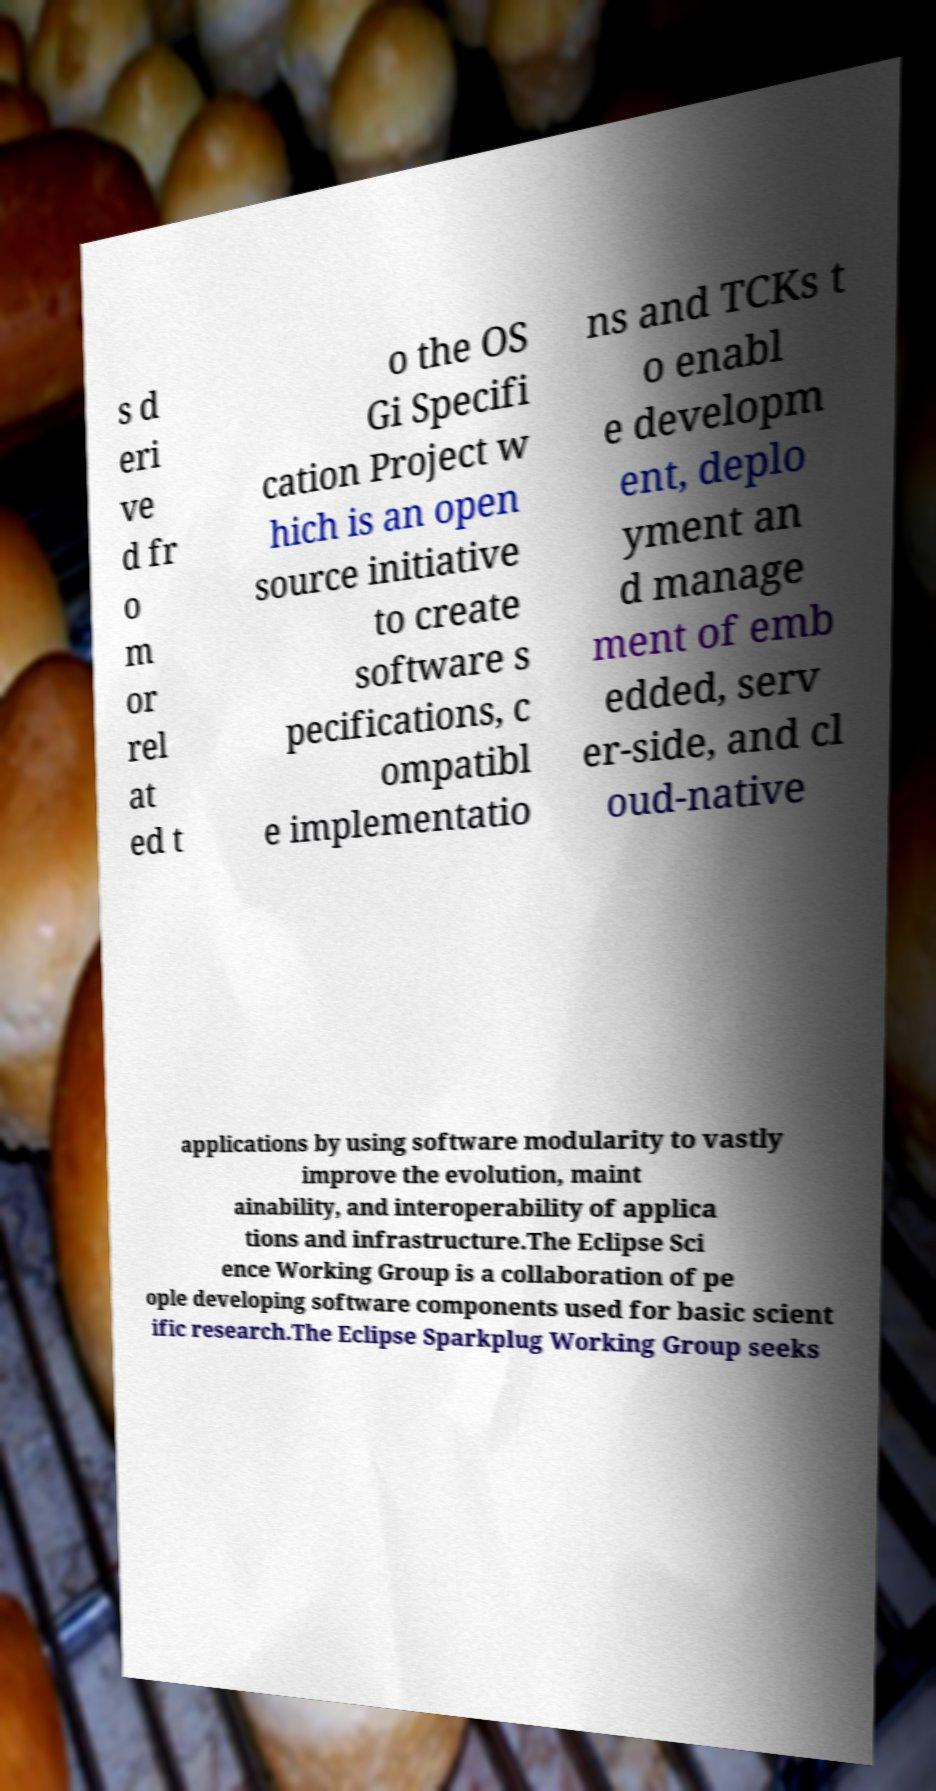Please read and relay the text visible in this image. What does it say? s d eri ve d fr o m or rel at ed t o the OS Gi Specifi cation Project w hich is an open source initiative to create software s pecifications, c ompatibl e implementatio ns and TCKs t o enabl e developm ent, deplo yment an d manage ment of emb edded, serv er-side, and cl oud-native applications by using software modularity to vastly improve the evolution, maint ainability, and interoperability of applica tions and infrastructure.The Eclipse Sci ence Working Group is a collaboration of pe ople developing software components used for basic scient ific research.The Eclipse Sparkplug Working Group seeks 